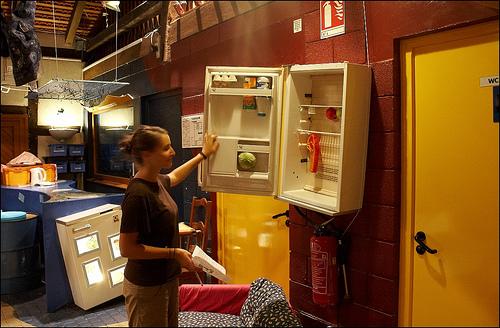What is orange and white in the picture?
Keep it brief. Door. Which arm is wearing a black strap?
Short answer required. Left. Does this room have safety standards?
Keep it brief. Yes. What is the red object under the open cabinet used for?
Answer briefly. Fire. 